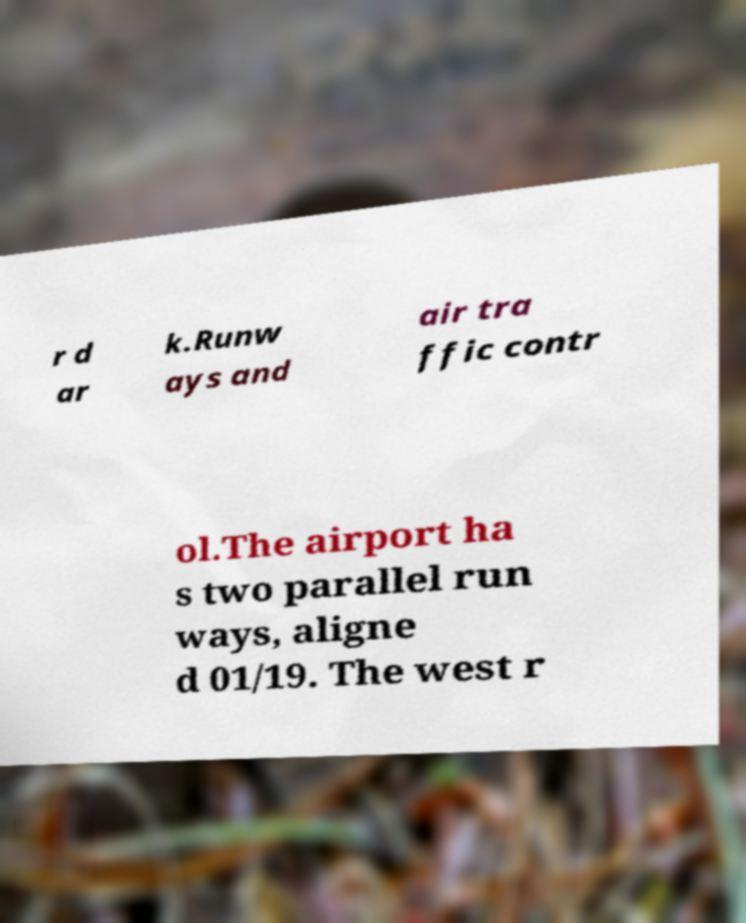Can you read and provide the text displayed in the image?This photo seems to have some interesting text. Can you extract and type it out for me? r d ar k.Runw ays and air tra ffic contr ol.The airport ha s two parallel run ways, aligne d 01/19. The west r 